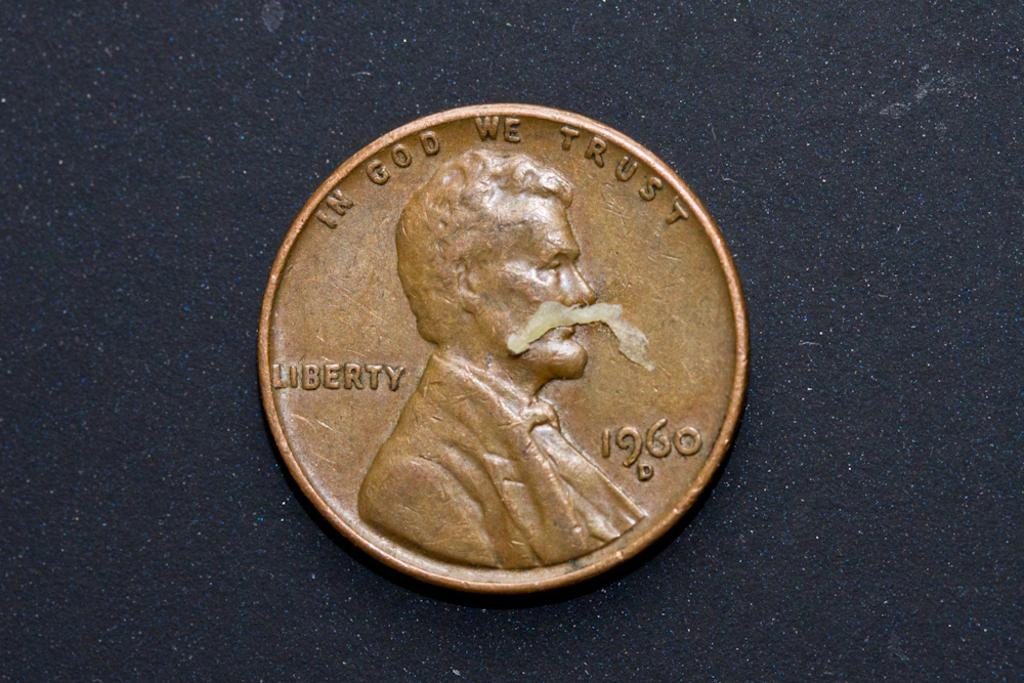Provide a one-sentence caption for the provided image. An American copper penny with the words In God We Trust, Liberty written on it along with the date of 1960. 